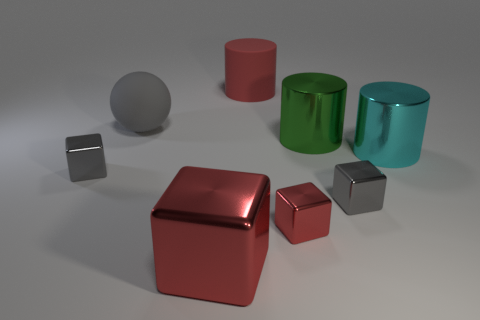What is the size of the matte object that is the same shape as the cyan shiny thing?
Ensure brevity in your answer.  Large. Does the big thing behind the matte sphere have the same material as the big sphere?
Offer a very short reply. Yes. What is the shape of the gray metallic thing to the left of the gray metal thing to the right of the small block that is on the left side of the large red metal block?
Give a very brief answer. Cube. Are there any matte cubes of the same size as the gray rubber ball?
Offer a very short reply. No. How big is the matte sphere?
Give a very brief answer. Large. What number of other cyan objects have the same size as the cyan shiny object?
Offer a very short reply. 0. Is the number of green metallic cylinders right of the big gray matte thing less than the number of large metallic things that are on the left side of the tiny red metallic block?
Offer a terse response. No. What is the size of the gray metallic thing to the right of the big red thing that is in front of the large object that is behind the large gray thing?
Your response must be concise. Small. There is a gray object that is on the left side of the green cylinder and in front of the large gray sphere; what size is it?
Make the answer very short. Small. The gray object that is in front of the tiny shiny thing left of the big red cylinder is what shape?
Provide a short and direct response. Cube. 